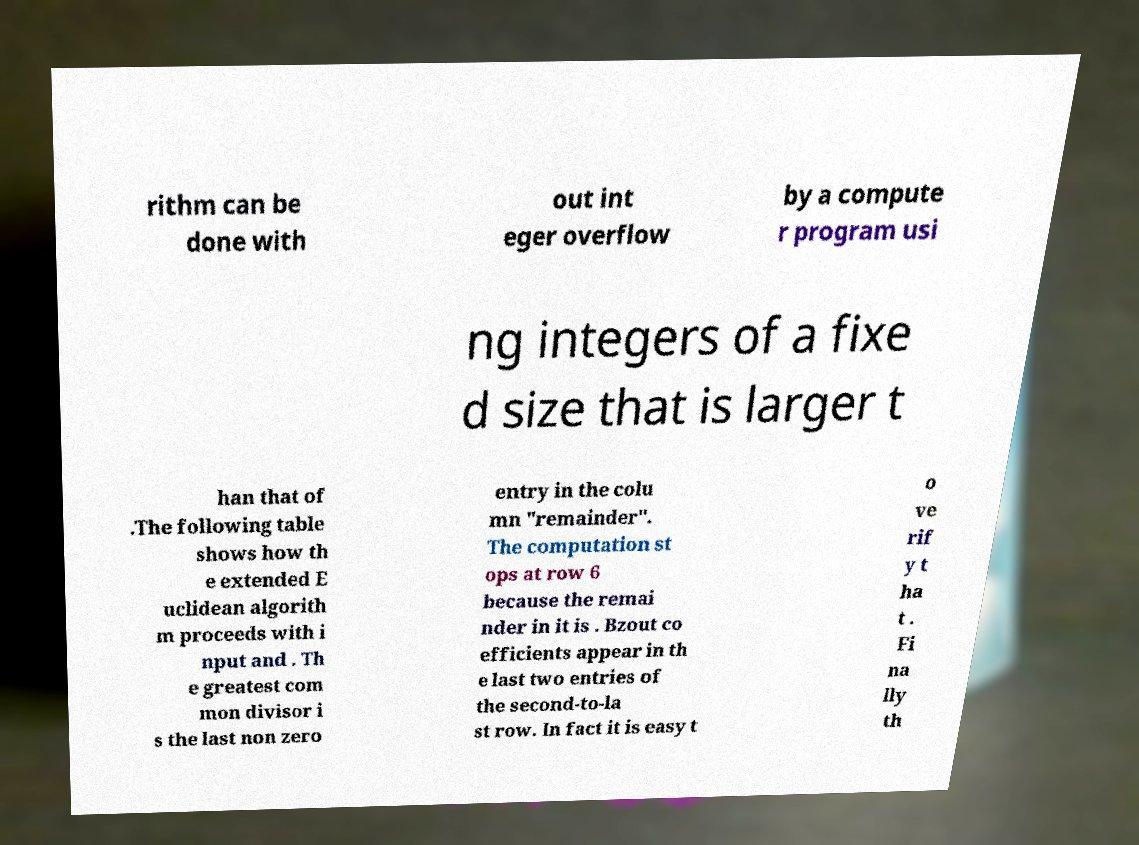Could you extract and type out the text from this image? rithm can be done with out int eger overflow by a compute r program usi ng integers of a fixe d size that is larger t han that of .The following table shows how th e extended E uclidean algorith m proceeds with i nput and . Th e greatest com mon divisor i s the last non zero entry in the colu mn "remainder". The computation st ops at row 6 because the remai nder in it is . Bzout co efficients appear in th e last two entries of the second-to-la st row. In fact it is easy t o ve rif y t ha t . Fi na lly th 